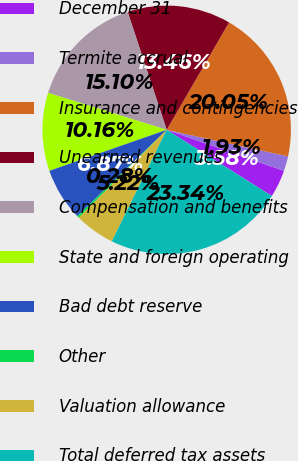Convert chart to OTSL. <chart><loc_0><loc_0><loc_500><loc_500><pie_chart><fcel>December 31<fcel>Termite accrual<fcel>Insurance and contingencies<fcel>Unearned revenues<fcel>Compensation and benefits<fcel>State and foreign operating<fcel>Bad debt reserve<fcel>Other<fcel>Valuation allowance<fcel>Total deferred tax assets<nl><fcel>3.58%<fcel>1.93%<fcel>20.05%<fcel>13.46%<fcel>15.1%<fcel>10.16%<fcel>6.87%<fcel>0.28%<fcel>5.22%<fcel>23.34%<nl></chart> 